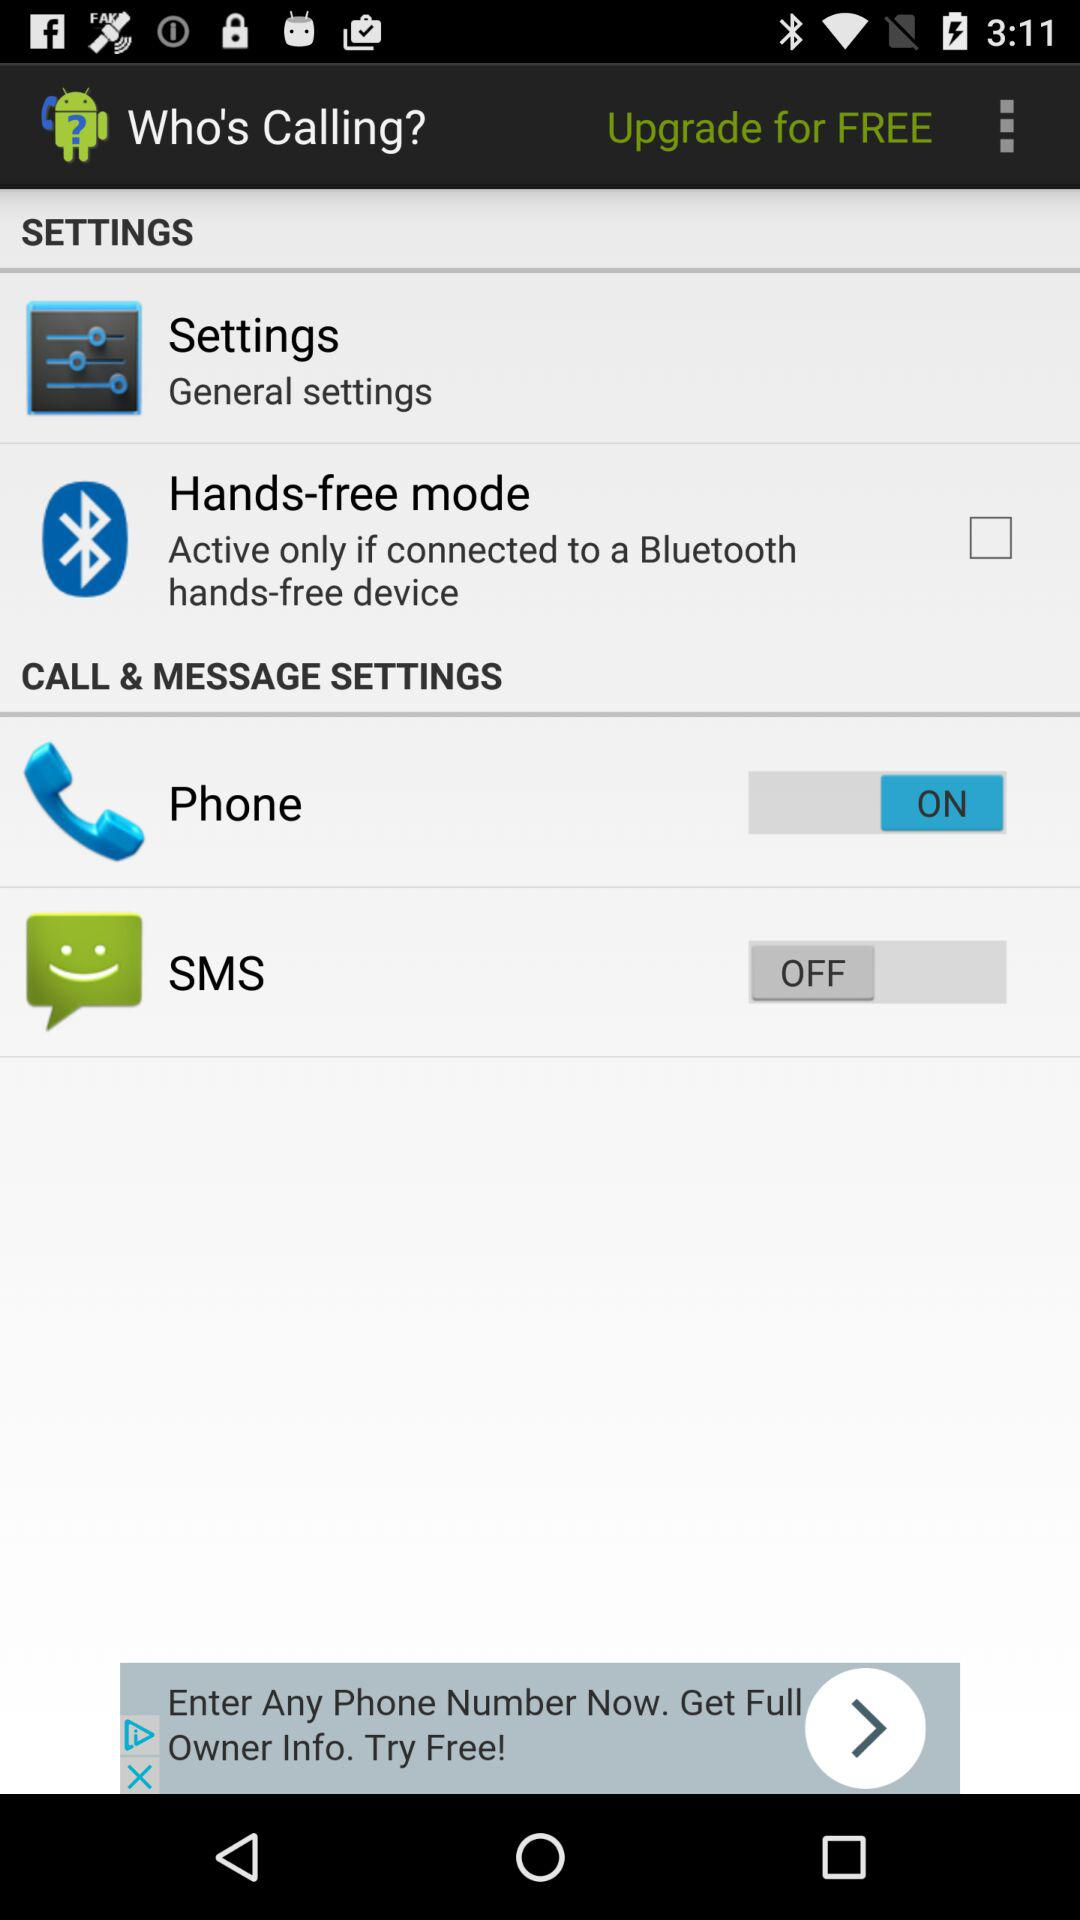What is the status of "Phone"? The status is "on". 